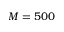<formula> <loc_0><loc_0><loc_500><loc_500>M = 5 0 0</formula> 